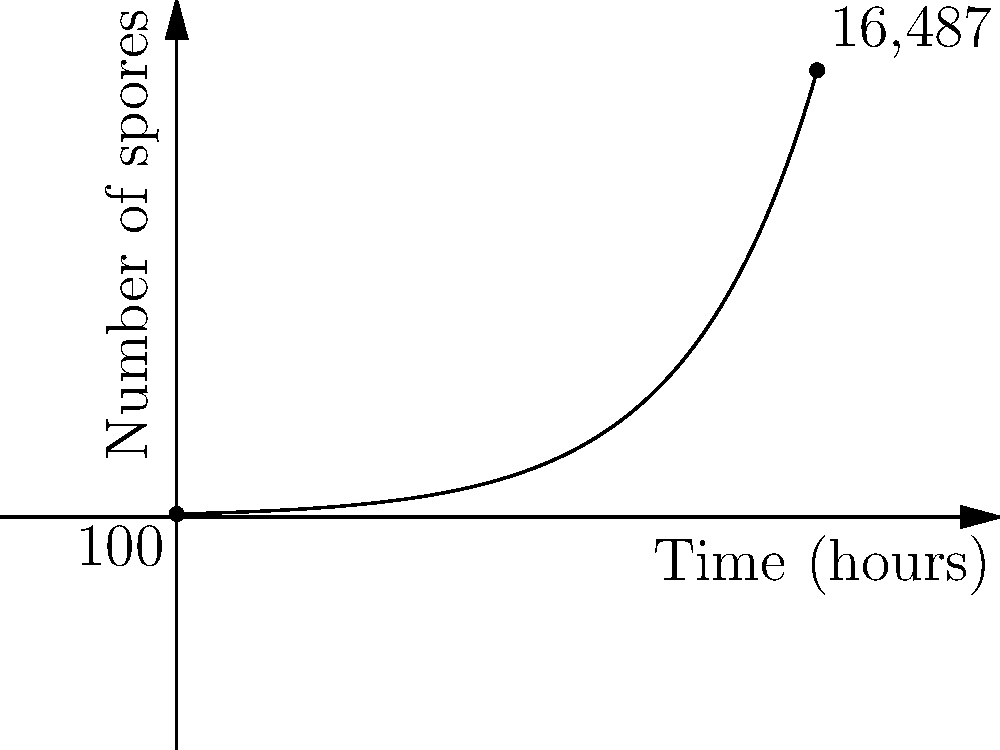Detective Mycologist, you've stumbled upon a peculiar case of mushroom spore proliferation! In your petri dish, you observe an initial population of 100 spores. After 10 hours, this number has mysteriously multiplied to 16,487 spores. Assuming exponential growth, what is the hourly growth rate of these enigmatic spores? Express your answer as a percentage, rounded to two decimal places. Let's unravel this fungal mystery step by step:

1) The exponential growth formula is:
   $N(t) = N_0 \cdot e^{rt}$
   where $N(t)$ is the number of spores at time $t$, $N_0$ is the initial number of spores, $r$ is the growth rate, and $t$ is the time.

2) We know:
   $N_0 = 100$ (initial spores)
   $N(10) = 16,487$ (spores after 10 hours)
   $t = 10$ hours

3) Let's plug these into our formula:
   $16,487 = 100 \cdot e^{10r}$

4) Divide both sides by 100:
   $164.87 = e^{10r}$

5) Take the natural log of both sides:
   $\ln(164.87) = 10r$

6) Solve for $r$:
   $r = \frac{\ln(164.87)}{10} \approx 0.5$

7) Convert to a percentage:
   $0.5 \times 100\% = 50\%$

Therefore, the hourly growth rate is approximately 50%.
Answer: 50% 